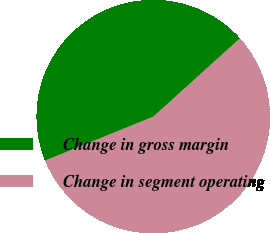Convert chart to OTSL. <chart><loc_0><loc_0><loc_500><loc_500><pie_chart><fcel>Change in gross margin<fcel>Change in segment operating<nl><fcel>44.44%<fcel>55.56%<nl></chart> 